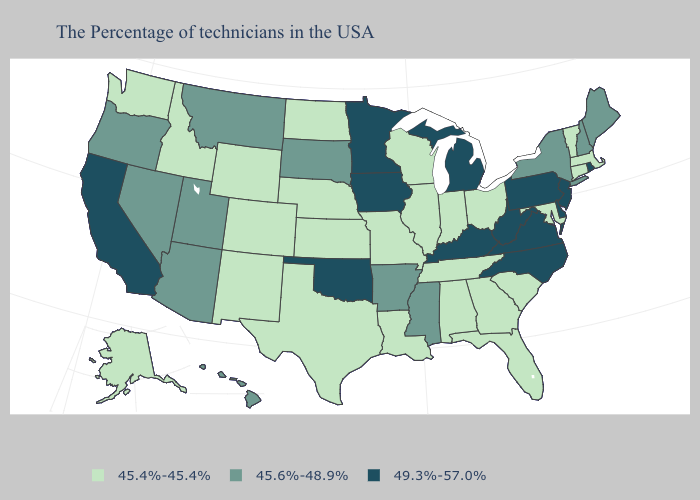Which states have the lowest value in the West?
Be succinct. Wyoming, Colorado, New Mexico, Idaho, Washington, Alaska. Name the states that have a value in the range 49.3%-57.0%?
Quick response, please. Rhode Island, New Jersey, Delaware, Pennsylvania, Virginia, North Carolina, West Virginia, Michigan, Kentucky, Minnesota, Iowa, Oklahoma, California. Does Kentucky have the highest value in the USA?
Answer briefly. Yes. Does Oregon have the highest value in the West?
Write a very short answer. No. Which states hav the highest value in the Northeast?
Write a very short answer. Rhode Island, New Jersey, Pennsylvania. What is the highest value in states that border Louisiana?
Answer briefly. 45.6%-48.9%. How many symbols are there in the legend?
Keep it brief. 3. Name the states that have a value in the range 45.4%-45.4%?
Give a very brief answer. Massachusetts, Vermont, Connecticut, Maryland, South Carolina, Ohio, Florida, Georgia, Indiana, Alabama, Tennessee, Wisconsin, Illinois, Louisiana, Missouri, Kansas, Nebraska, Texas, North Dakota, Wyoming, Colorado, New Mexico, Idaho, Washington, Alaska. Does Georgia have the lowest value in the USA?
Answer briefly. Yes. What is the value of Wyoming?
Keep it brief. 45.4%-45.4%. Does the first symbol in the legend represent the smallest category?
Short answer required. Yes. Name the states that have a value in the range 49.3%-57.0%?
Quick response, please. Rhode Island, New Jersey, Delaware, Pennsylvania, Virginia, North Carolina, West Virginia, Michigan, Kentucky, Minnesota, Iowa, Oklahoma, California. Which states hav the highest value in the Northeast?
Quick response, please. Rhode Island, New Jersey, Pennsylvania. Name the states that have a value in the range 45.4%-45.4%?
Concise answer only. Massachusetts, Vermont, Connecticut, Maryland, South Carolina, Ohio, Florida, Georgia, Indiana, Alabama, Tennessee, Wisconsin, Illinois, Louisiana, Missouri, Kansas, Nebraska, Texas, North Dakota, Wyoming, Colorado, New Mexico, Idaho, Washington, Alaska. Does Maryland have the highest value in the South?
Answer briefly. No. 